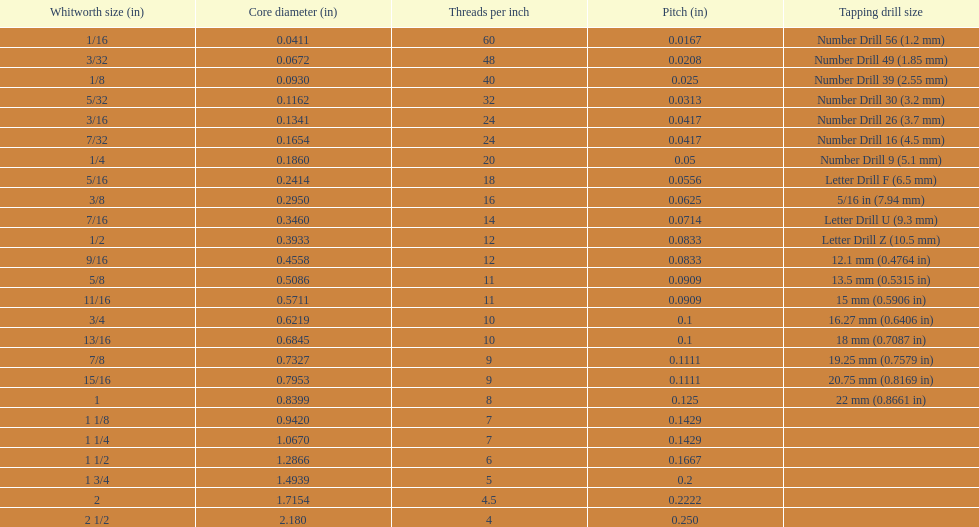What are the typical whitworth dimensions in inches? 1/16, 3/32, 1/8, 5/32, 3/16, 7/32, 1/4, 5/16, 3/8, 7/16, 1/2, 9/16, 5/8, 11/16, 3/4, 13/16, 7/8, 15/16, 1, 1 1/8, 1 1/4, 1 1/2, 1 3/4, 2, 2 1/2. For the 3/16 size, how many threads per inch are there? 24. Is there another size (in inches) with an identical thread count? 7/32. 